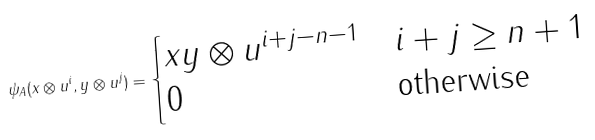Convert formula to latex. <formula><loc_0><loc_0><loc_500><loc_500>\psi _ { A } ( x \otimes u ^ { i } , y \otimes u ^ { j } ) = \begin{cases} x y \otimes u ^ { i + j - n - 1 } & i + j \geq n + 1 \\ 0 & \text {otherwise} \end{cases}</formula> 